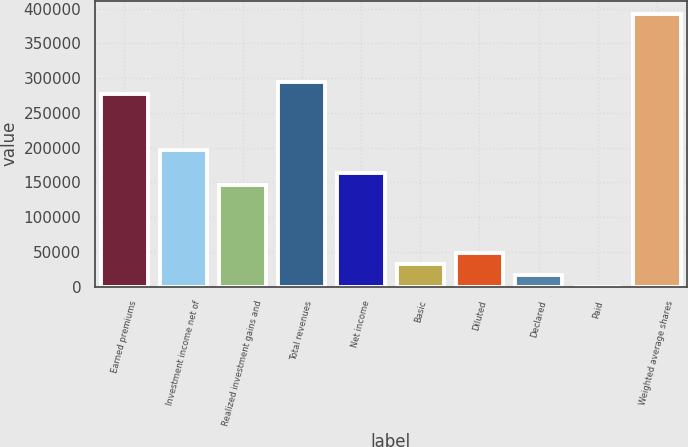Convert chart to OTSL. <chart><loc_0><loc_0><loc_500><loc_500><bar_chart><fcel>Earned premiums<fcel>Investment income net of<fcel>Realized investment gains and<fcel>Total revenues<fcel>Net income<fcel>Basic<fcel>Diluted<fcel>Declared<fcel>Paid<fcel>Weighted average shares<nl><fcel>277565<fcel>195928<fcel>146947<fcel>293892<fcel>163274<fcel>32656.1<fcel>48983.3<fcel>16328.8<fcel>1.58<fcel>391855<nl></chart> 